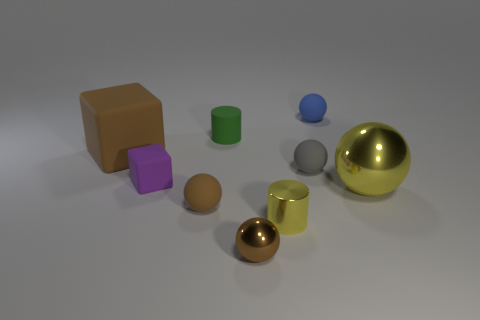Is the number of purple blocks that are right of the big yellow metallic sphere greater than the number of yellow metallic objects that are behind the green cylinder?
Provide a succinct answer. No. What number of other objects are the same size as the brown rubber ball?
Your answer should be compact. 6. Is the shape of the purple matte object the same as the brown matte thing right of the large cube?
Provide a succinct answer. No. How many metallic things are yellow cylinders or red objects?
Give a very brief answer. 1. Is there a large rubber thing that has the same color as the rubber cylinder?
Give a very brief answer. No. Are any large yellow balls visible?
Provide a succinct answer. Yes. Is the big yellow metal object the same shape as the tiny brown metal object?
Offer a very short reply. Yes. How many small objects are purple cubes or blue rubber things?
Provide a succinct answer. 2. The big block is what color?
Provide a succinct answer. Brown. What is the shape of the yellow metallic thing on the left side of the big object that is in front of the brown cube?
Offer a terse response. Cylinder. 